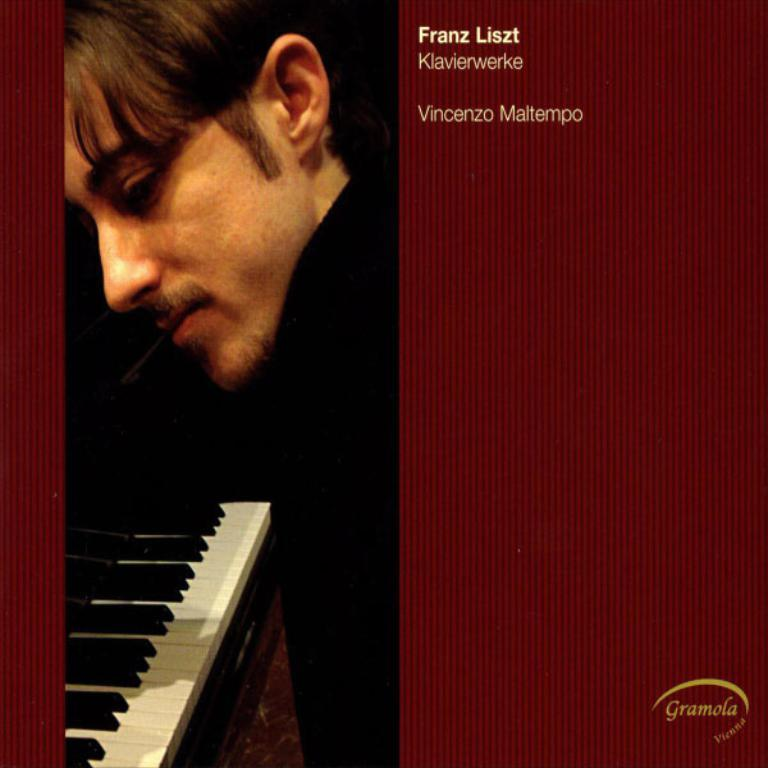Who is present in the image? There is a man in the image. What object can be seen in the image? There is a piano in the image. Where is text located in the image? There is text in the top right corner and the bottom right corner of the image. How many lizards are crawling on the piano in the image? There are no lizards present in the image. What is the angle of the piano in the image? The angle of the piano cannot be determined from the image, as it appears to be straight and parallel to the ground. 